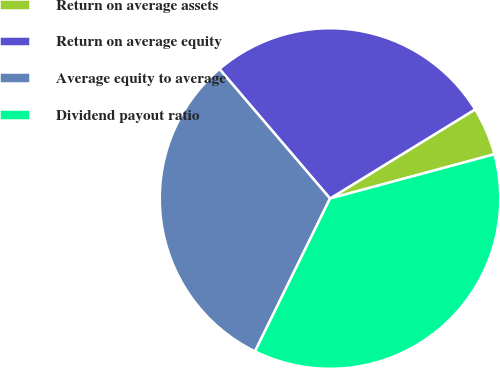<chart> <loc_0><loc_0><loc_500><loc_500><pie_chart><fcel>Return on average assets<fcel>Return on average equity<fcel>Average equity to average<fcel>Dividend payout ratio<nl><fcel>4.58%<fcel>27.48%<fcel>31.49%<fcel>36.45%<nl></chart> 